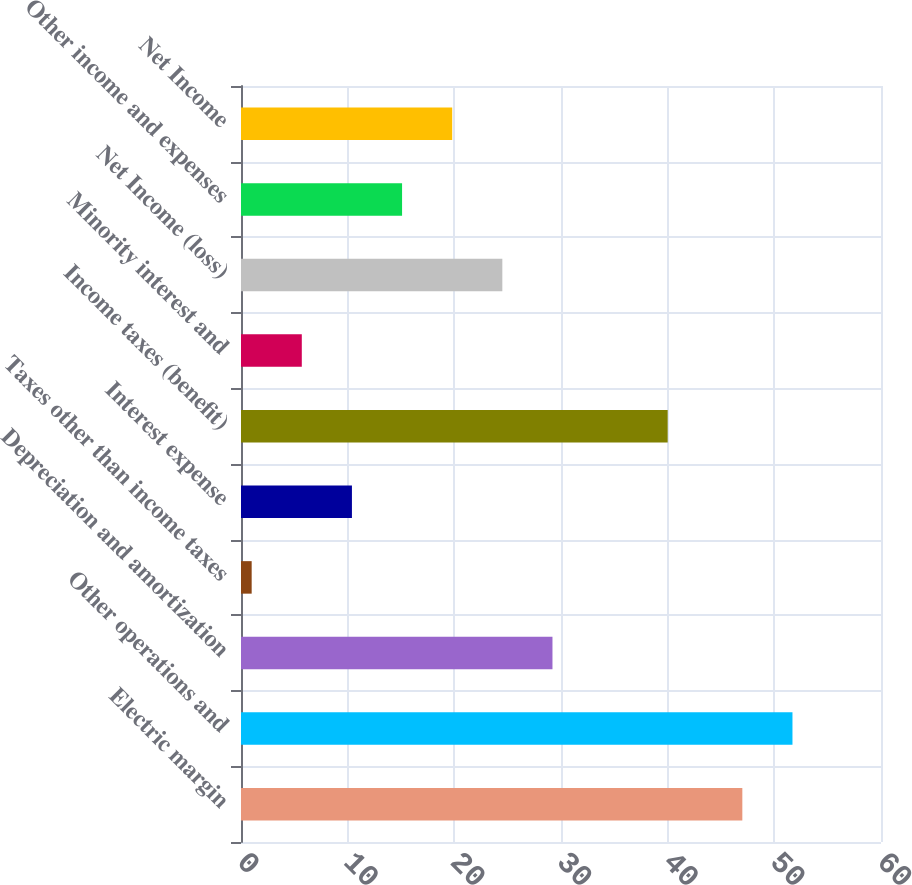Convert chart. <chart><loc_0><loc_0><loc_500><loc_500><bar_chart><fcel>Electric margin<fcel>Other operations and<fcel>Depreciation and amortization<fcel>Taxes other than income taxes<fcel>Interest expense<fcel>Income taxes (benefit)<fcel>Minority interest and<fcel>Net Income (loss)<fcel>Other income and expenses<fcel>Net Income<nl><fcel>47<fcel>51.7<fcel>29.2<fcel>1<fcel>10.4<fcel>40<fcel>5.7<fcel>24.5<fcel>15.1<fcel>19.8<nl></chart> 